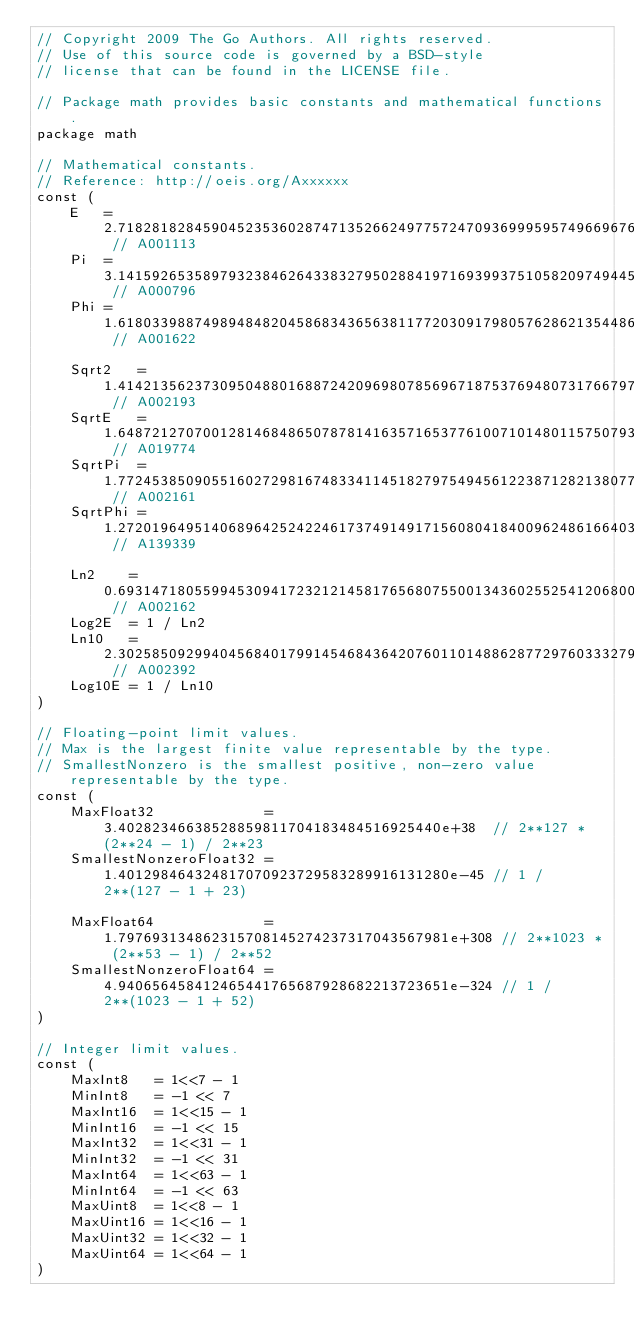<code> <loc_0><loc_0><loc_500><loc_500><_Go_>// Copyright 2009 The Go Authors. All rights reserved.
// Use of this source code is governed by a BSD-style
// license that can be found in the LICENSE file.

// Package math provides basic constants and mathematical functions.
package math

// Mathematical constants.
// Reference: http://oeis.org/Axxxxxx
const (
	E   = 2.71828182845904523536028747135266249775724709369995957496696763 // A001113
	Pi  = 3.14159265358979323846264338327950288419716939937510582097494459 // A000796
	Phi = 1.61803398874989484820458683436563811772030917980576286213544862 // A001622

	Sqrt2   = 1.41421356237309504880168872420969807856967187537694807317667974 // A002193
	SqrtE   = 1.64872127070012814684865078781416357165377610071014801157507931 // A019774
	SqrtPi  = 1.77245385090551602729816748334114518279754945612238712821380779 // A002161
	SqrtPhi = 1.27201964951406896425242246173749149171560804184009624861664038 // A139339

	Ln2    = 0.693147180559945309417232121458176568075500134360255254120680009 // A002162
	Log2E  = 1 / Ln2
	Ln10   = 2.30258509299404568401799145468436420760110148862877297603332790 // A002392
	Log10E = 1 / Ln10
)

// Floating-point limit values.
// Max is the largest finite value representable by the type.
// SmallestNonzero is the smallest positive, non-zero value representable by the type.
const (
	MaxFloat32             = 3.40282346638528859811704183484516925440e+38  // 2**127 * (2**24 - 1) / 2**23
	SmallestNonzeroFloat32 = 1.401298464324817070923729583289916131280e-45 // 1 / 2**(127 - 1 + 23)

	MaxFloat64             = 1.797693134862315708145274237317043567981e+308 // 2**1023 * (2**53 - 1) / 2**52
	SmallestNonzeroFloat64 = 4.940656458412465441765687928682213723651e-324 // 1 / 2**(1023 - 1 + 52)
)

// Integer limit values.
const (
	MaxInt8   = 1<<7 - 1
	MinInt8   = -1 << 7
	MaxInt16  = 1<<15 - 1
	MinInt16  = -1 << 15
	MaxInt32  = 1<<31 - 1
	MinInt32  = -1 << 31
	MaxInt64  = 1<<63 - 1
	MinInt64  = -1 << 63
	MaxUint8  = 1<<8 - 1
	MaxUint16 = 1<<16 - 1
	MaxUint32 = 1<<32 - 1
	MaxUint64 = 1<<64 - 1
)</code> 